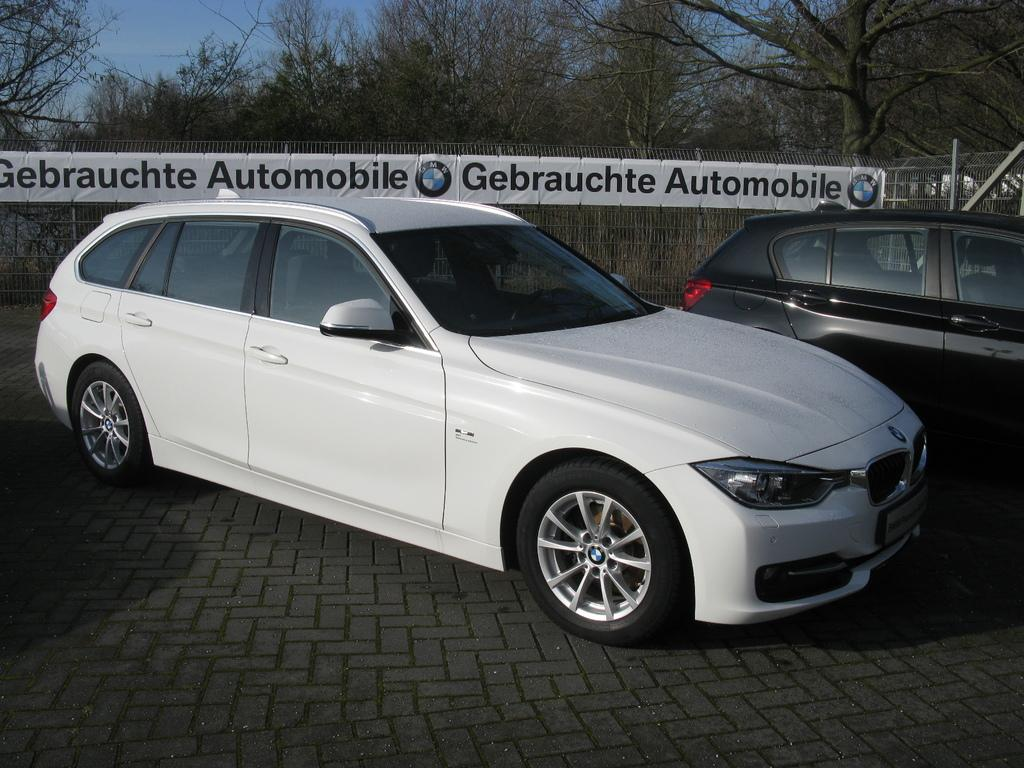What type of vehicles can be seen in the image? There are cars in the image. What is hanging in the back of the image? There is a banner with text and logos in the back. What type of structure is present in the image? There are railings in the image. What can be seen in the distance in the image? There are trees and the sky visible in the background of the image. How much honey is being used to fuel the cars in the image? There is no mention of honey being used to fuel the cars in the image. Cars typically run on gasoline or electricity, not honey. 